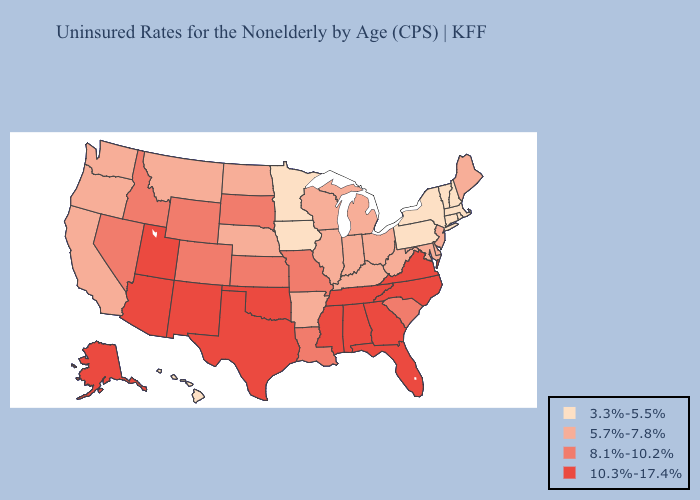Which states have the lowest value in the USA?
Write a very short answer. Connecticut, Hawaii, Iowa, Massachusetts, Minnesota, New Hampshire, New York, Pennsylvania, Rhode Island, Vermont. What is the lowest value in the South?
Quick response, please. 5.7%-7.8%. Does Illinois have the lowest value in the USA?
Keep it brief. No. Among the states that border New Mexico , does Colorado have the highest value?
Give a very brief answer. No. What is the lowest value in the South?
Concise answer only. 5.7%-7.8%. Among the states that border Texas , does New Mexico have the lowest value?
Quick response, please. No. What is the lowest value in the Northeast?
Be succinct. 3.3%-5.5%. What is the highest value in the USA?
Be succinct. 10.3%-17.4%. What is the value of Washington?
Write a very short answer. 5.7%-7.8%. Does Vermont have a lower value than Hawaii?
Concise answer only. No. What is the highest value in the Northeast ?
Answer briefly. 5.7%-7.8%. What is the lowest value in states that border Ohio?
Short answer required. 3.3%-5.5%. What is the value of Massachusetts?
Quick response, please. 3.3%-5.5%. How many symbols are there in the legend?
Concise answer only. 4. Name the states that have a value in the range 8.1%-10.2%?
Write a very short answer. Colorado, Idaho, Kansas, Louisiana, Missouri, Nevada, South Carolina, South Dakota, Wyoming. 